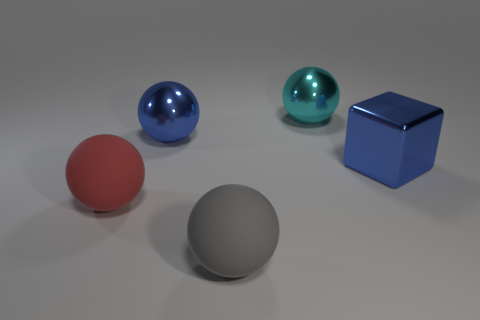What number of objects are red matte balls or large purple blocks?
Ensure brevity in your answer.  1. Is the shape of the red rubber thing the same as the blue thing that is to the left of the metal cube?
Keep it short and to the point. Yes. What is the shape of the large matte thing that is in front of the large red matte sphere?
Your answer should be compact. Sphere. Is the gray object the same shape as the cyan metallic object?
Offer a very short reply. Yes. The other metallic thing that is the same shape as the large cyan metal object is what size?
Your response must be concise. Large. Does the blue object that is left of the blue cube have the same size as the big cyan metallic object?
Provide a succinct answer. Yes. There is a thing that is in front of the blue block and to the left of the gray matte thing; how big is it?
Keep it short and to the point. Large. What material is the large thing that is the same color as the block?
Offer a terse response. Metal. What number of metallic things are the same color as the block?
Keep it short and to the point. 1. Are there an equal number of large red objects that are behind the large red rubber object and large cyan matte balls?
Offer a very short reply. Yes. 